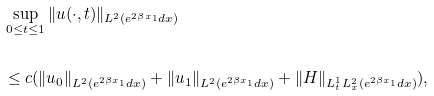Convert formula to latex. <formula><loc_0><loc_0><loc_500><loc_500>& \sup _ { 0 \leq t \leq 1 } \| u ( \cdot , t ) \| _ { L ^ { 2 } ( e ^ { 2 \beta x _ { 1 } } d x ) } \\ \\ & \leq c ( \| u _ { 0 } \| _ { L ^ { 2 } ( e ^ { 2 \beta x _ { 1 } } d x ) } + \| u _ { 1 } \| _ { L ^ { 2 } ( e ^ { 2 \beta x _ { 1 } } d x ) } + \| H \| _ { L ^ { 1 } _ { t } L ^ { 2 } _ { x } ( e ^ { 2 \beta x _ { 1 } } d x ) } ) ,</formula> 